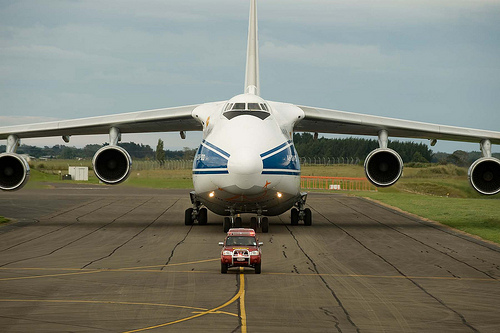<image>
Can you confirm if the truck is under the plane? No. The truck is not positioned under the plane. The vertical relationship between these objects is different. 